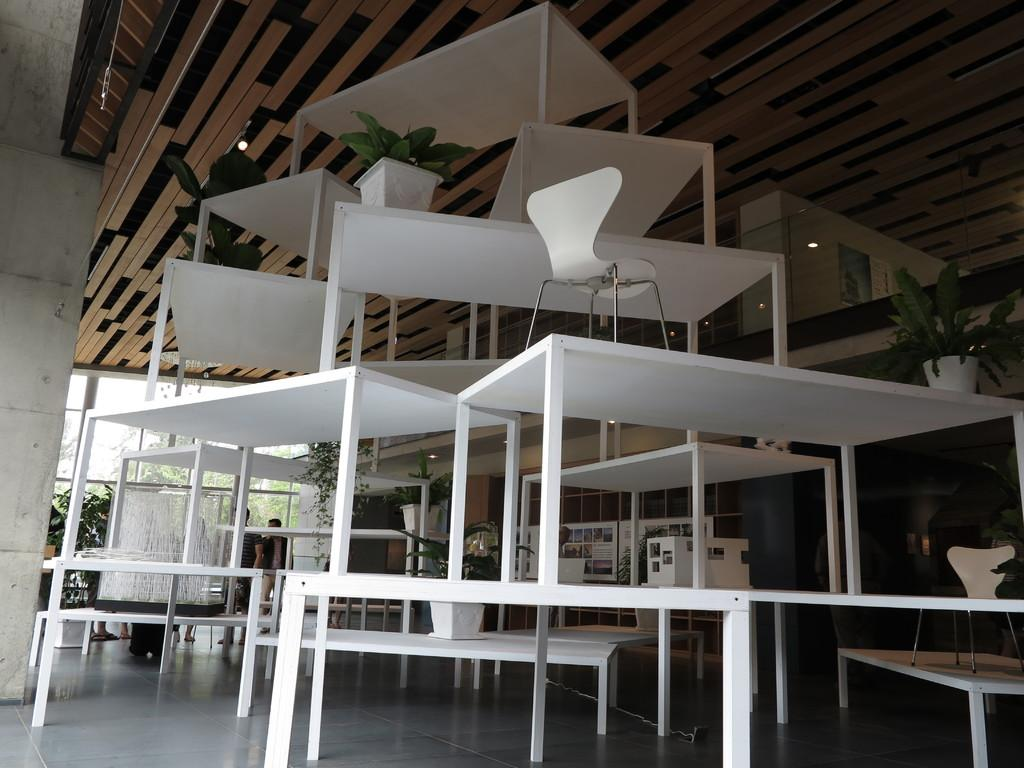How are the tables arranged in the image? The tables are placed one above the other in the image. What type of furniture is present in the image besides the tables? There are chairs in the image. What can be seen in the background of the image? There are people and plants in the background of the image. What material is used for the ceiling in the image? There is a wooden ceiling visible in the image. What type of stamp can be seen on the wooden ceiling in the image? There is no stamp present on the wooden ceiling in the image. What type of scene is depicted on the tables in the image? The tables are stacked one above the other, and there is no scene depicted on them. 